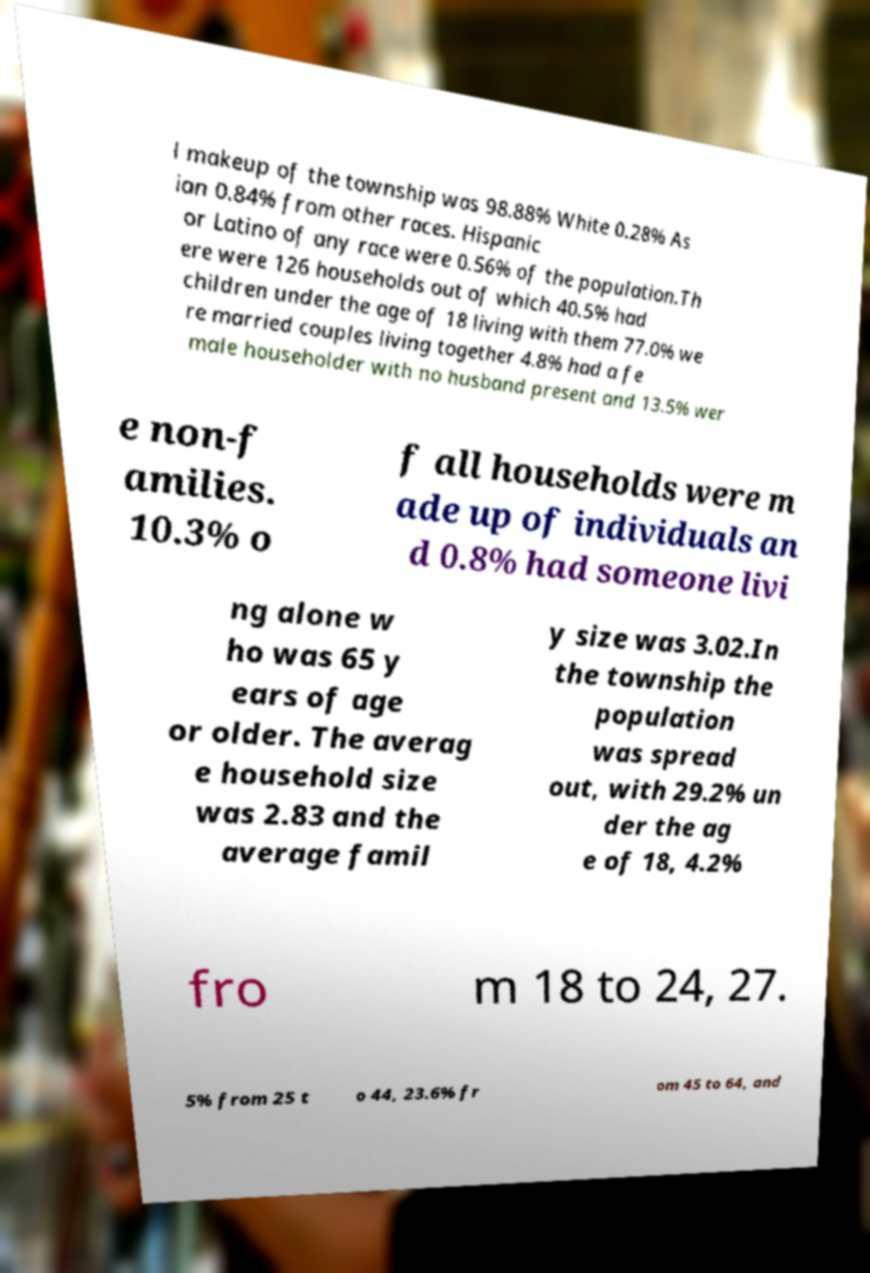There's text embedded in this image that I need extracted. Can you transcribe it verbatim? l makeup of the township was 98.88% White 0.28% As ian 0.84% from other races. Hispanic or Latino of any race were 0.56% of the population.Th ere were 126 households out of which 40.5% had children under the age of 18 living with them 77.0% we re married couples living together 4.8% had a fe male householder with no husband present and 13.5% wer e non-f amilies. 10.3% o f all households were m ade up of individuals an d 0.8% had someone livi ng alone w ho was 65 y ears of age or older. The averag e household size was 2.83 and the average famil y size was 3.02.In the township the population was spread out, with 29.2% un der the ag e of 18, 4.2% fro m 18 to 24, 27. 5% from 25 t o 44, 23.6% fr om 45 to 64, and 